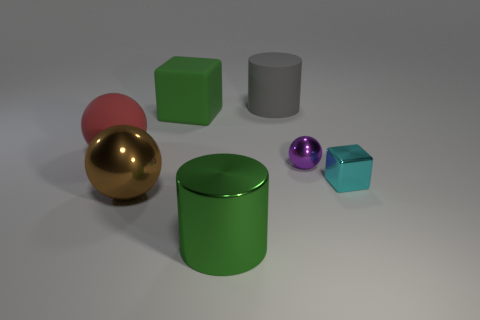Add 1 brown objects. How many objects exist? 8 Subtract all big spheres. How many spheres are left? 1 Subtract all spheres. How many objects are left? 4 Add 2 big blocks. How many big blocks exist? 3 Subtract 0 blue cylinders. How many objects are left? 7 Subtract all green cubes. Subtract all green balls. How many cubes are left? 1 Subtract all big purple spheres. Subtract all small metallic balls. How many objects are left? 6 Add 7 brown spheres. How many brown spheres are left? 8 